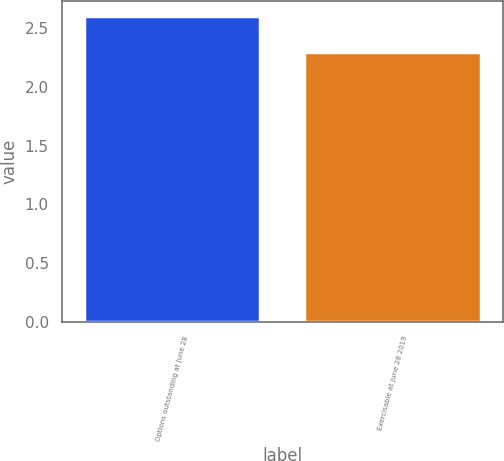Convert chart. <chart><loc_0><loc_0><loc_500><loc_500><bar_chart><fcel>Options outstanding at June 28<fcel>Exercisable at June 28 2019<nl><fcel>2.6<fcel>2.3<nl></chart> 